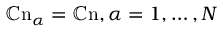<formula> <loc_0><loc_0><loc_500><loc_500>\mathbb { C } n _ { \alpha } = \mathbb { C } n , \alpha = 1 , \dots , N</formula> 